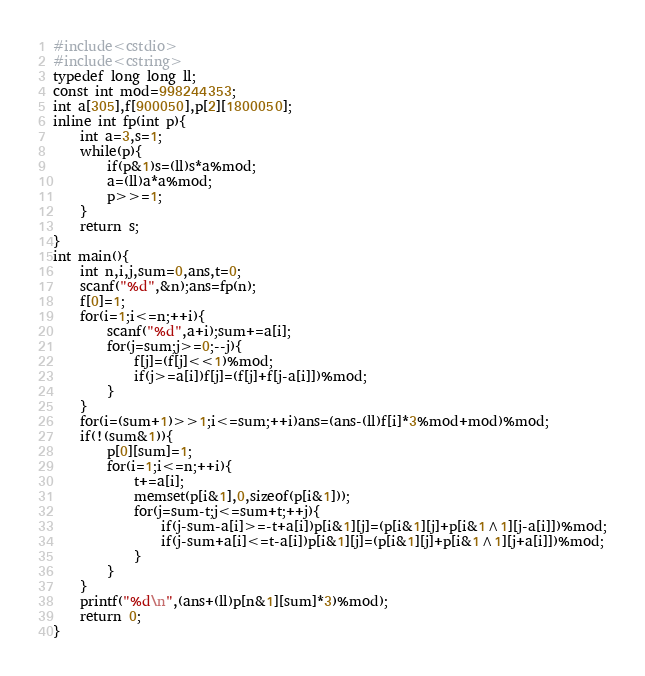Convert code to text. <code><loc_0><loc_0><loc_500><loc_500><_C++_>#include<cstdio>
#include<cstring>
typedef long long ll;
const int mod=998244353;
int a[305],f[900050],p[2][1800050];
inline int fp(int p){
	int a=3,s=1;
	while(p){
		if(p&1)s=(ll)s*a%mod;
		a=(ll)a*a%mod;
		p>>=1;
	}
	return s;
}
int main(){
	int n,i,j,sum=0,ans,t=0;
	scanf("%d",&n);ans=fp(n);
	f[0]=1;
	for(i=1;i<=n;++i){
		scanf("%d",a+i);sum+=a[i];
		for(j=sum;j>=0;--j){
			f[j]=(f[j]<<1)%mod;
			if(j>=a[i])f[j]=(f[j]+f[j-a[i]])%mod;
		}
	}
	for(i=(sum+1)>>1;i<=sum;++i)ans=(ans-(ll)f[i]*3%mod+mod)%mod;
	if(!(sum&1)){
		p[0][sum]=1;
		for(i=1;i<=n;++i){
			t+=a[i];
			memset(p[i&1],0,sizeof(p[i&1]));
			for(j=sum-t;j<=sum+t;++j){
				if(j-sum-a[i]>=-t+a[i])p[i&1][j]=(p[i&1][j]+p[i&1^1][j-a[i]])%mod;
				if(j-sum+a[i]<=t-a[i])p[i&1][j]=(p[i&1][j]+p[i&1^1][j+a[i]])%mod;
			}
		}
	}
	printf("%d\n",(ans+(ll)p[n&1][sum]*3)%mod);
	return 0;
} </code> 